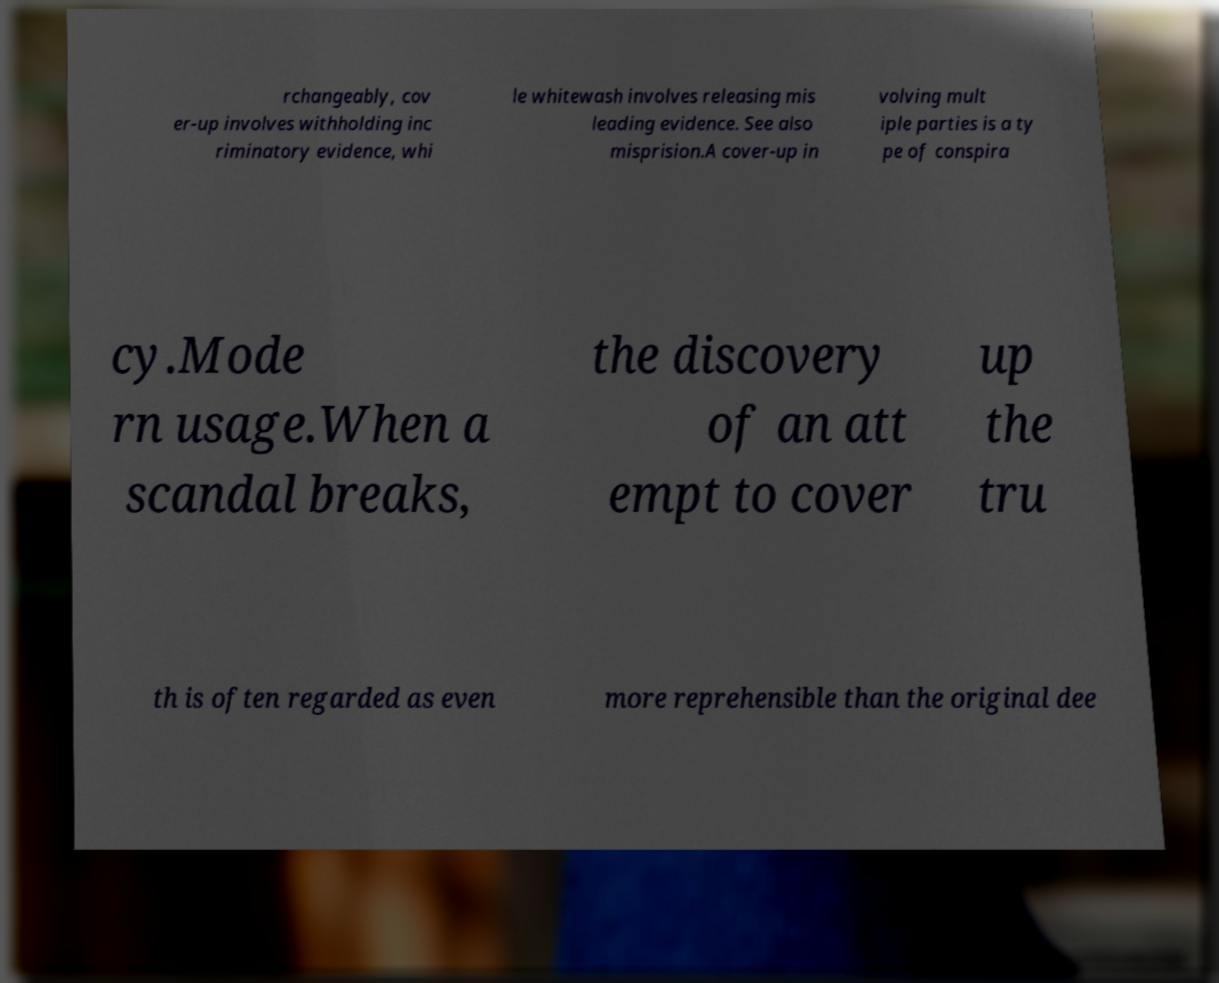Can you accurately transcribe the text from the provided image for me? rchangeably, cov er-up involves withholding inc riminatory evidence, whi le whitewash involves releasing mis leading evidence. See also misprision.A cover-up in volving mult iple parties is a ty pe of conspira cy.Mode rn usage.When a scandal breaks, the discovery of an att empt to cover up the tru th is often regarded as even more reprehensible than the original dee 